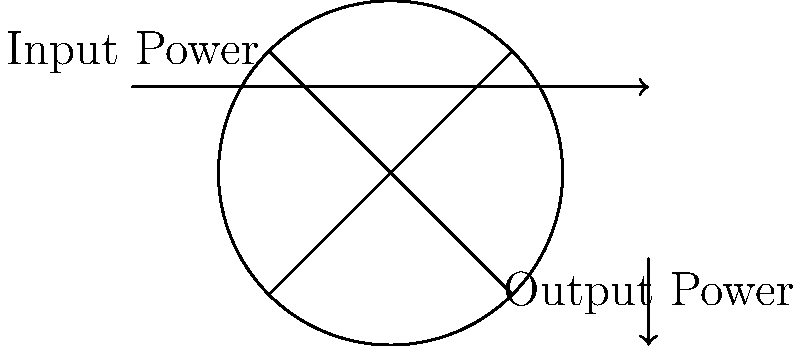A traditional water wheel used for irrigation has an input power of 500 W from the flowing water. If the output power for lifting water is measured to be 375 W, what is the mechanical efficiency of this water wheel? To find the mechanical efficiency of the water wheel, we need to follow these steps:

1. Understand the concept of mechanical efficiency:
   Mechanical efficiency is the ratio of output power to input power, expressed as a percentage.

2. Identify the given information:
   - Input power (P_in) = 500 W
   - Output power (P_out) = 375 W

3. Apply the formula for mechanical efficiency:
   Efficiency (η) = (P_out / P_in) × 100%

4. Substitute the values into the formula:
   η = (375 W / 500 W) × 100%

5. Perform the calculation:
   η = 0.75 × 100% = 75%

Therefore, the mechanical efficiency of the water wheel is 75%.
Answer: 75% 